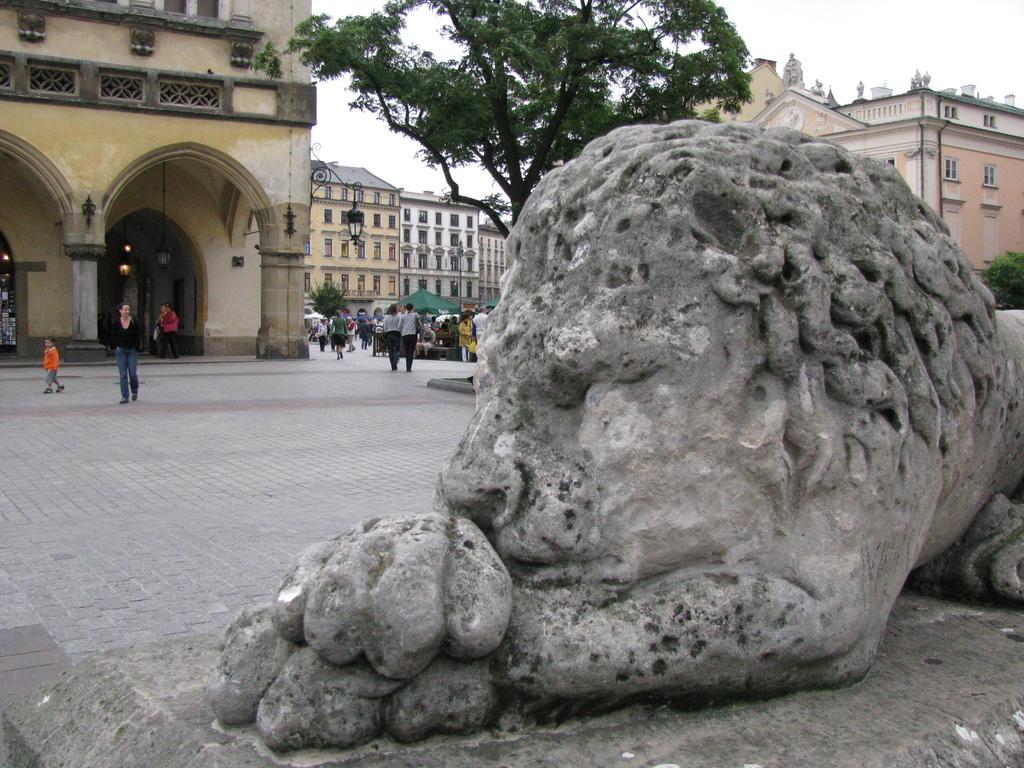Could you give a brief overview of what you see in this image? In this image I see a statue over here and I see the path on which there are number of people. In the background I see number of buildings and I see a tree over here and I see the sky and I see few more trees. 